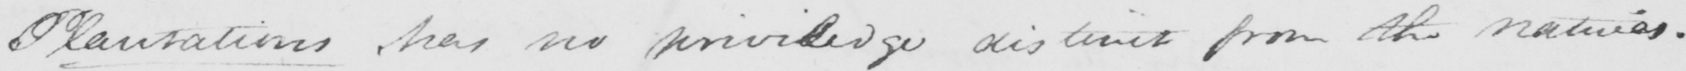Can you read and transcribe this handwriting? Plantations , has no privilege distinct from the natives . 